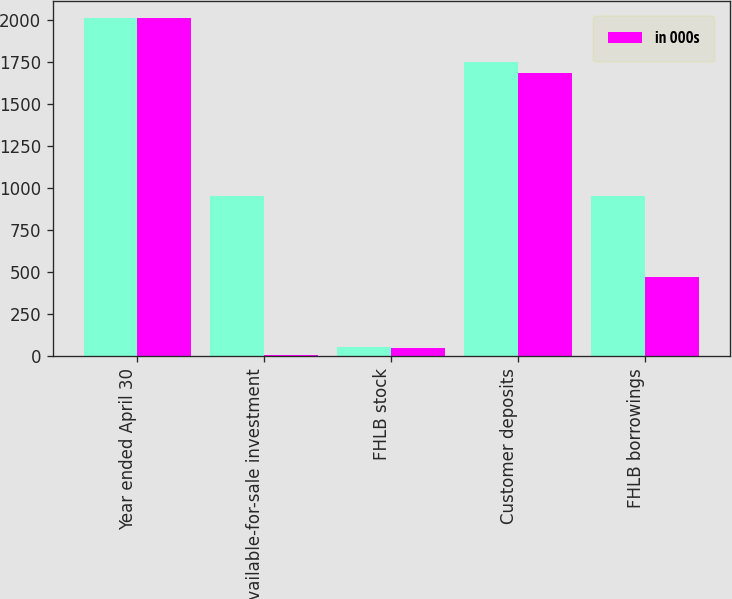Convert chart to OTSL. <chart><loc_0><loc_0><loc_500><loc_500><stacked_bar_chart><ecel><fcel>Year ended April 30<fcel>Available-for-sale investment<fcel>FHLB stock<fcel>Customer deposits<fcel>FHLB borrowings<nl><fcel>nan<fcel>2012<fcel>954<fcel>58<fcel>1753<fcel>954<nl><fcel>in 000s<fcel>2011<fcel>7<fcel>52<fcel>1686<fcel>471<nl></chart> 